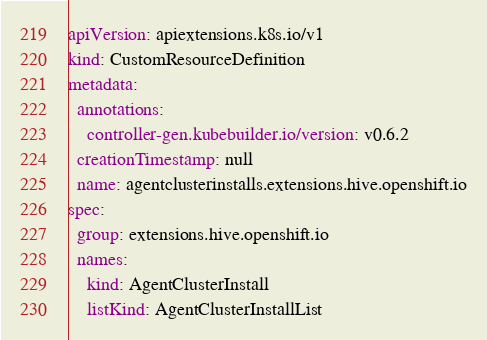<code> <loc_0><loc_0><loc_500><loc_500><_YAML_>apiVersion: apiextensions.k8s.io/v1
kind: CustomResourceDefinition
metadata:
  annotations:
    controller-gen.kubebuilder.io/version: v0.6.2
  creationTimestamp: null
  name: agentclusterinstalls.extensions.hive.openshift.io
spec:
  group: extensions.hive.openshift.io
  names:
    kind: AgentClusterInstall
    listKind: AgentClusterInstallList</code> 